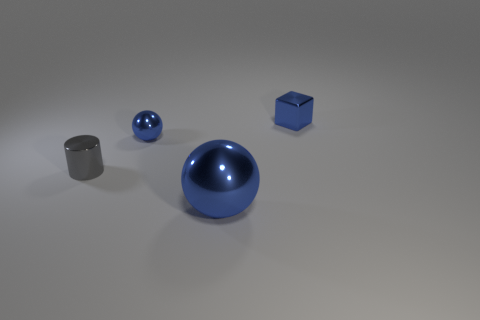There is a small blue cube; are there any tiny things in front of it?
Provide a short and direct response. Yes. Is there a small brown matte thing that has the same shape as the large metallic object?
Give a very brief answer. No. Do the tiny blue metallic object in front of the tiny cube and the metallic object to the left of the small blue ball have the same shape?
Give a very brief answer. No. Are there any gray matte things that have the same size as the gray metal object?
Provide a short and direct response. No. Is the number of gray things on the right side of the tiny shiny sphere the same as the number of small metal things to the left of the big ball?
Your response must be concise. No. Are the small blue object that is on the left side of the tiny cube and the blue thing that is in front of the gray shiny cylinder made of the same material?
Offer a terse response. Yes. What is the tiny gray thing made of?
Keep it short and to the point. Metal. What number of other things are there of the same color as the big metallic ball?
Your answer should be compact. 2. Is the color of the cube the same as the large thing?
Ensure brevity in your answer.  Yes. How many tiny blue metal things are there?
Your answer should be compact. 2. 